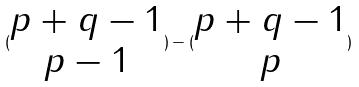Convert formula to latex. <formula><loc_0><loc_0><loc_500><loc_500>( \begin{matrix} p + q - 1 \\ p - 1 \end{matrix} ) - ( \begin{matrix} p + q - 1 \\ p \end{matrix} )</formula> 